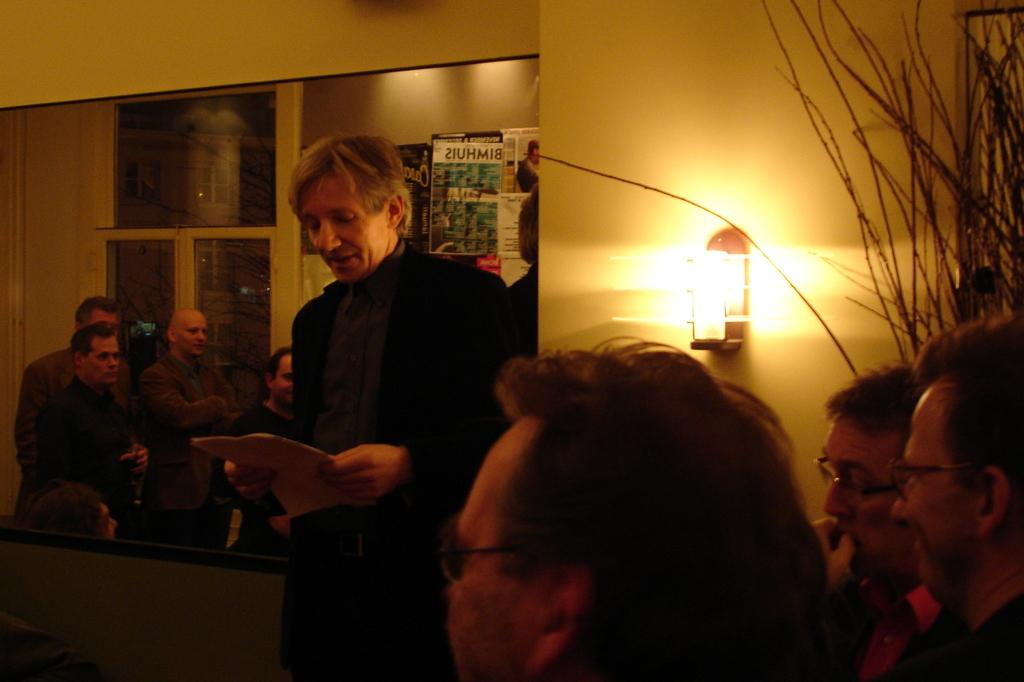What can be seen on the right side of the image? There are people on the right side of the image. What is present in the background of the image? There is a mirror and a wall in the background of the image. What does the mirror reflect in the image? The mirror reflects the people in the image. Can you describe the lighting in the image? There is a light in the image. What color is the heart that is being thought about by the people in the image? There is no mention of a heart or thoughts in the image; it only shows people, a mirror, a wall, and a light. What type of thread is being used to sew the people's clothes in the image? There is no information about the people's clothes or any thread in the image. 